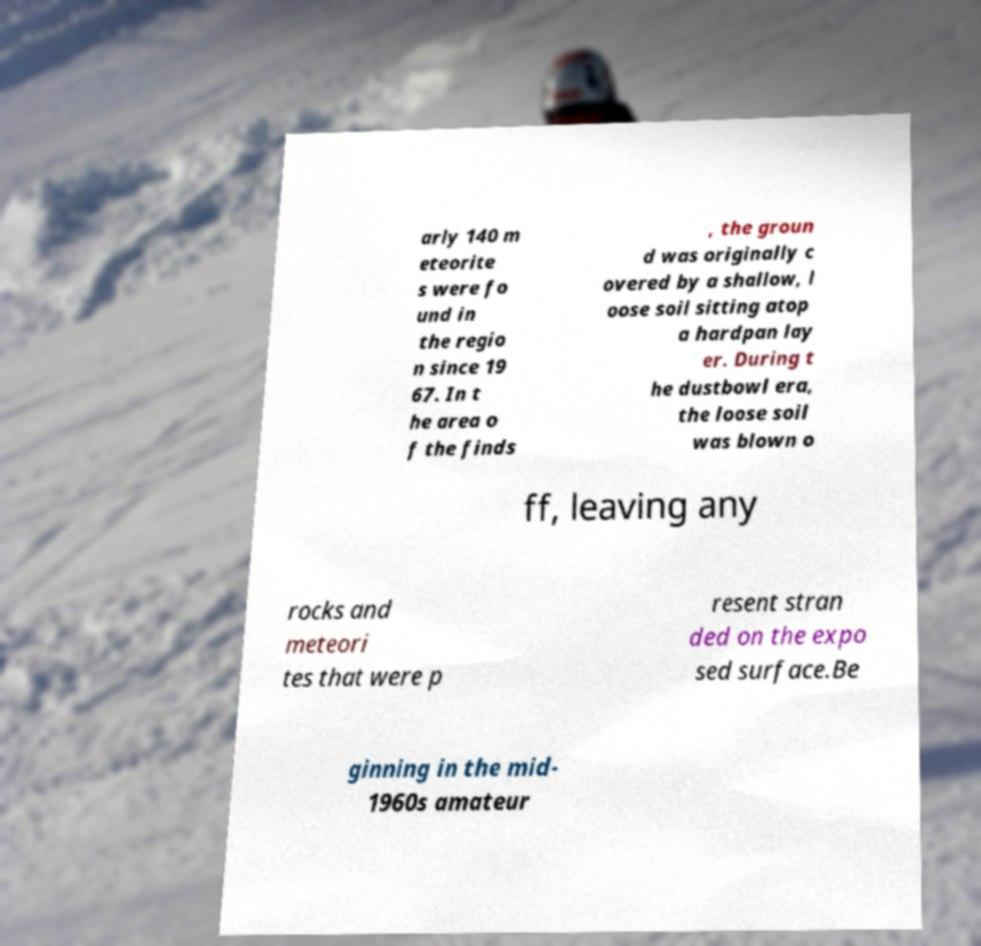I need the written content from this picture converted into text. Can you do that? arly 140 m eteorite s were fo und in the regio n since 19 67. In t he area o f the finds , the groun d was originally c overed by a shallow, l oose soil sitting atop a hardpan lay er. During t he dustbowl era, the loose soil was blown o ff, leaving any rocks and meteori tes that were p resent stran ded on the expo sed surface.Be ginning in the mid- 1960s amateur 